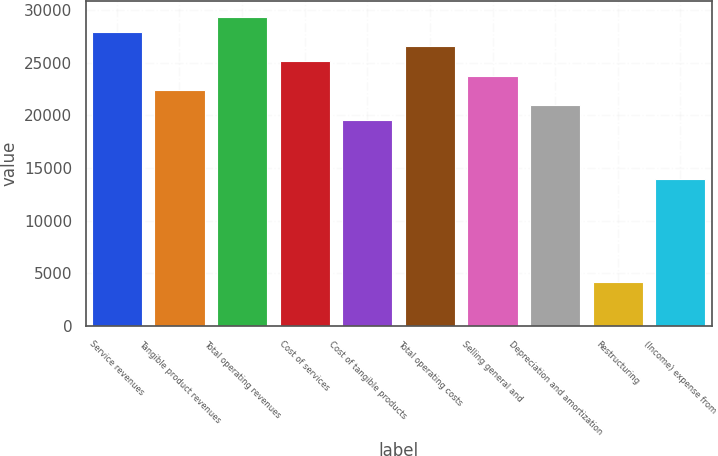Convert chart to OTSL. <chart><loc_0><loc_0><loc_500><loc_500><bar_chart><fcel>Service revenues<fcel>Tangible product revenues<fcel>Total operating revenues<fcel>Cost of services<fcel>Cost of tangible products<fcel>Total operating costs<fcel>Selling general and<fcel>Depreciation and amortization<fcel>Restructuring<fcel>(Income) expense from<nl><fcel>27965.8<fcel>22372.7<fcel>29364.1<fcel>25169.2<fcel>19576.1<fcel>26567.5<fcel>23771<fcel>20974.4<fcel>4195.05<fcel>13983<nl></chart> 